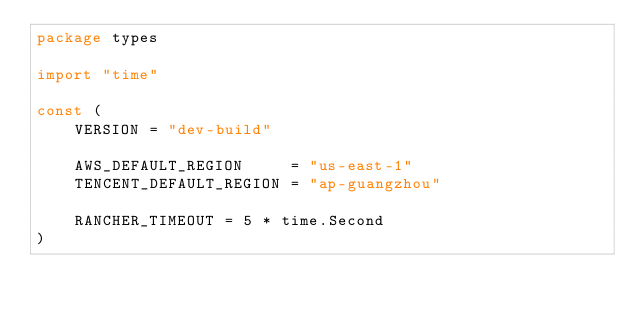Convert code to text. <code><loc_0><loc_0><loc_500><loc_500><_Go_>package types

import "time"

const (
	VERSION = "dev-build"

	AWS_DEFAULT_REGION     = "us-east-1"
	TENCENT_DEFAULT_REGION = "ap-guangzhou"

	RANCHER_TIMEOUT = 5 * time.Second
)
</code> 